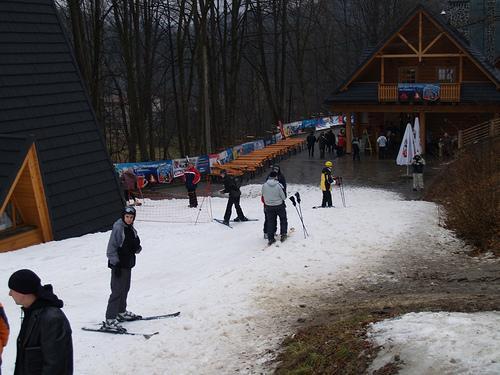How many people are there?
Give a very brief answer. 2. 